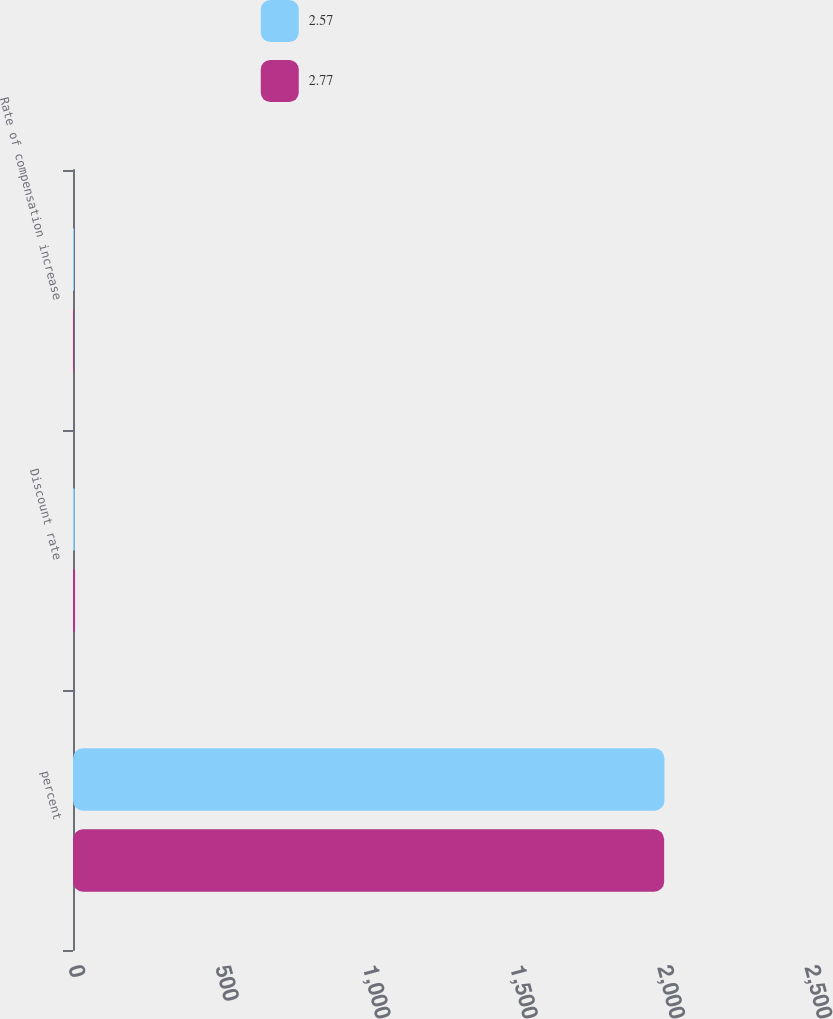Convert chart. <chart><loc_0><loc_0><loc_500><loc_500><stacked_bar_chart><ecel><fcel>percent<fcel>Discount rate<fcel>Rate of compensation increase<nl><fcel>2.57<fcel>2009<fcel>5.75<fcel>3.5<nl><fcel>2.77<fcel>2008<fcel>7<fcel>3.5<nl></chart> 